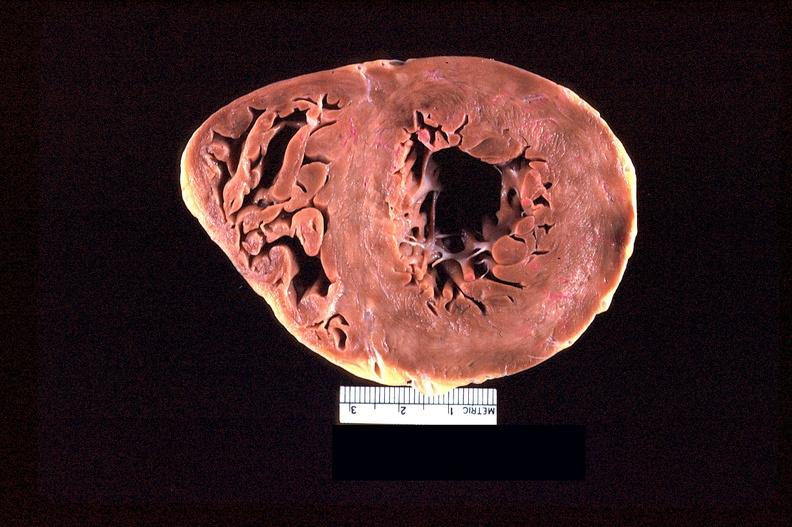s cardiovascular present?
Answer the question using a single word or phrase. Yes 